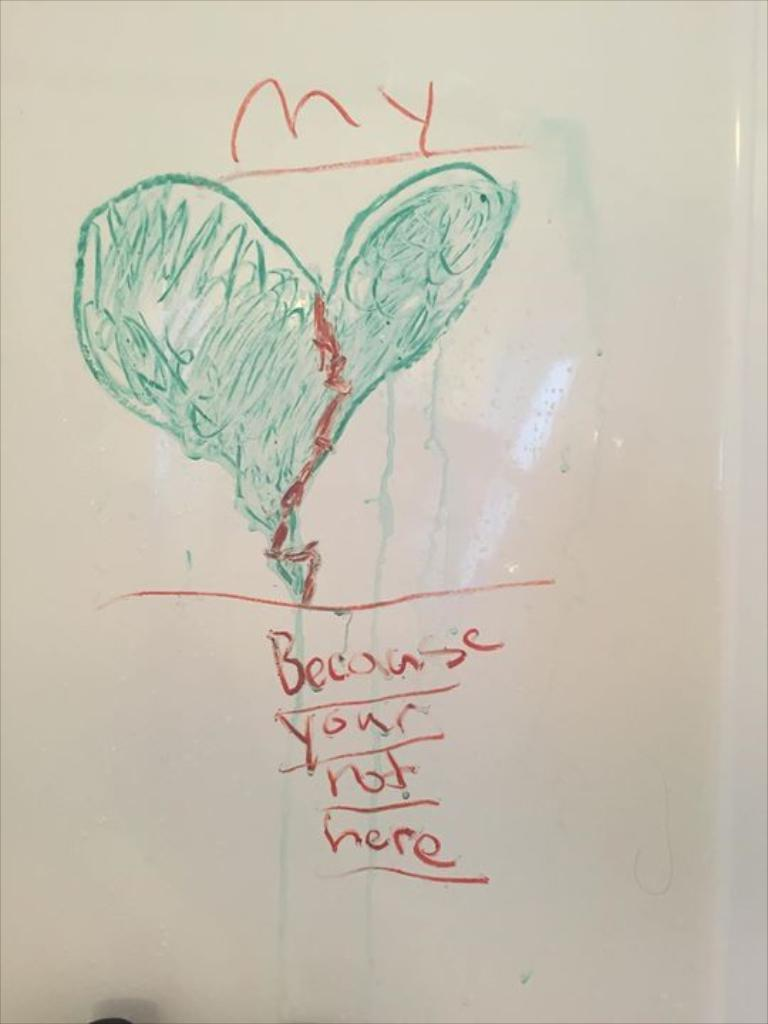<image>
Give a short and clear explanation of the subsequent image. A drawn image of a heat on a white board that says, 'because your not here'. 